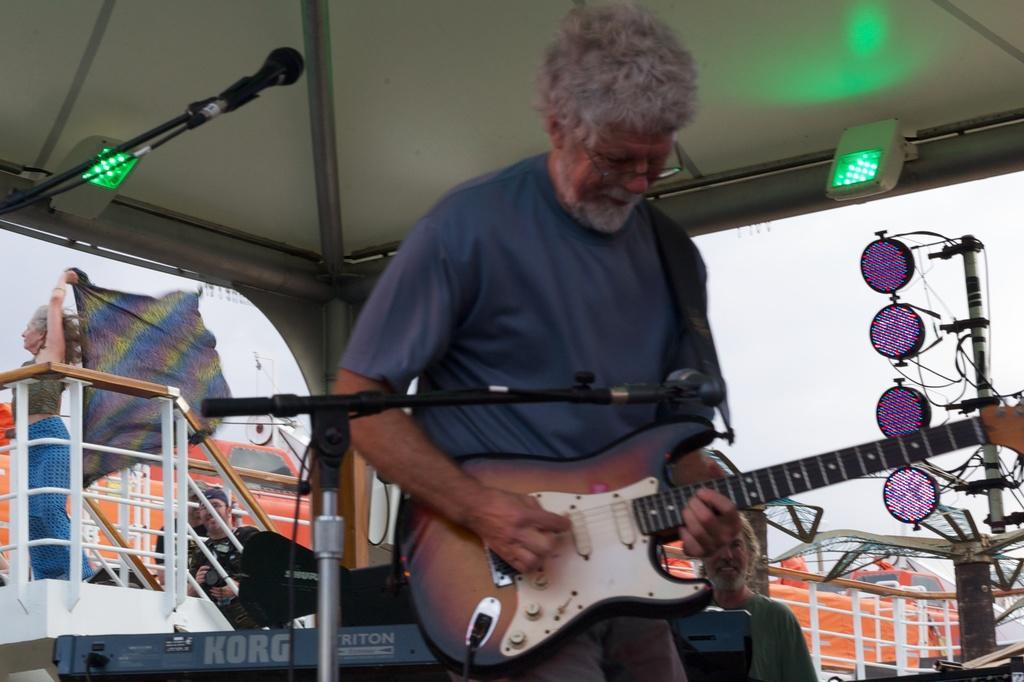Could you give a brief overview of what you see in this image? In this image the person is holding the guitar and he could be talking something behind the person some,vehicle,woman,mike and some signal are there in the background is cloudy. 